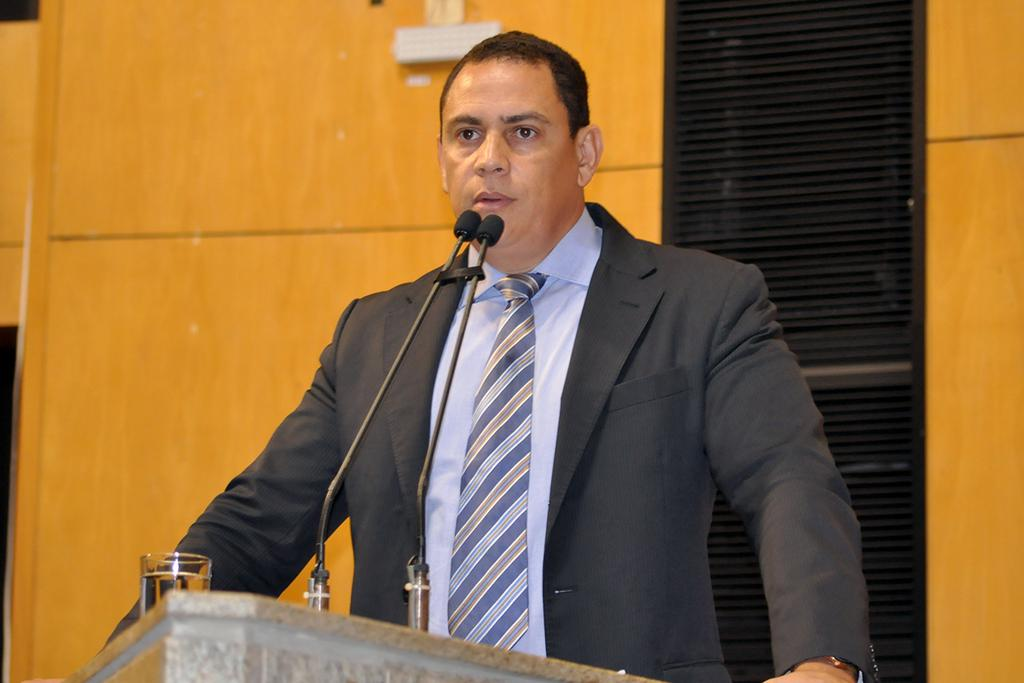What is the person in the image doing? There is a person standing in front of the podium. What can be found on the podium? There are mics and a water glass on the podium. What is visible in the background of the image? There is a wall in the background of the image, and there are objects on the wall. How does the pollution affect the wave in the image? There is no pollution or wave present in the image. 